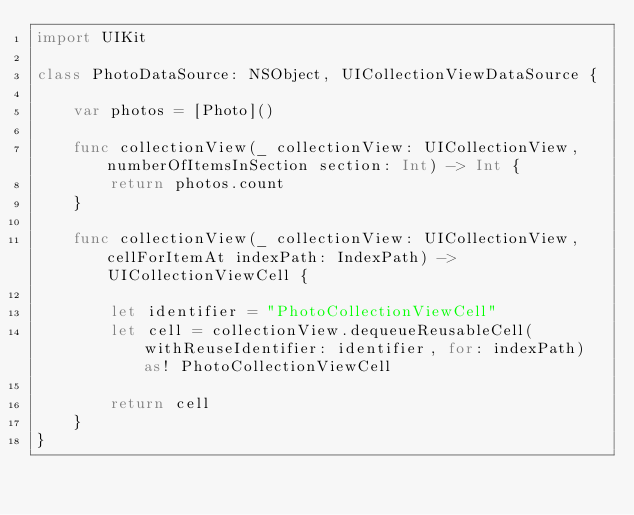Convert code to text. <code><loc_0><loc_0><loc_500><loc_500><_Swift_>import UIKit

class PhotoDataSource: NSObject, UICollectionViewDataSource {
    
    var photos = [Photo]()
    
    func collectionView(_ collectionView: UICollectionView, numberOfItemsInSection section: Int) -> Int {
        return photos.count
    }
    
    func collectionView(_ collectionView: UICollectionView, cellForItemAt indexPath: IndexPath) -> UICollectionViewCell {
        
        let identifier = "PhotoCollectionViewCell"
        let cell = collectionView.dequeueReusableCell(withReuseIdentifier: identifier, for: indexPath) as! PhotoCollectionViewCell
        
        return cell
    }  
}
</code> 